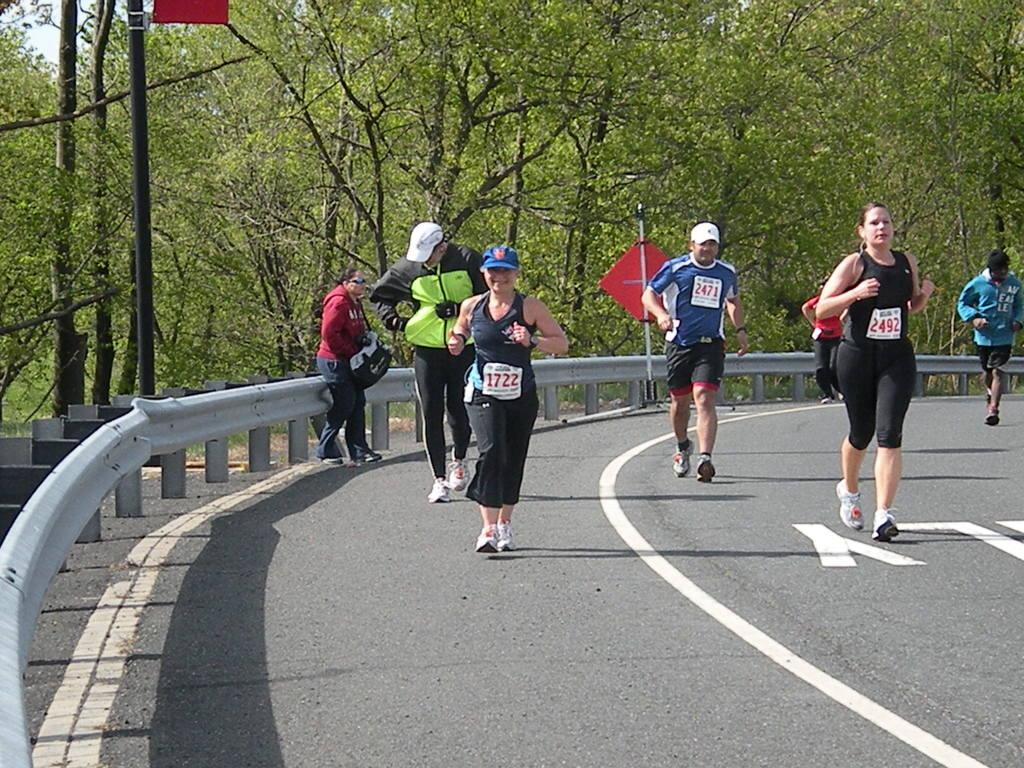What are the people in the image doing? The people in the image are running. On what surface are the people running? The people are running on a road. What type of vegetation can be seen in the image? There are green trees visible in the image. How many umbrellas are being held by the men in the image? There are no men or umbrellas present in the image. What type of account is being discussed by the people in the image? There is no discussion of an account in the image; the people are running. 